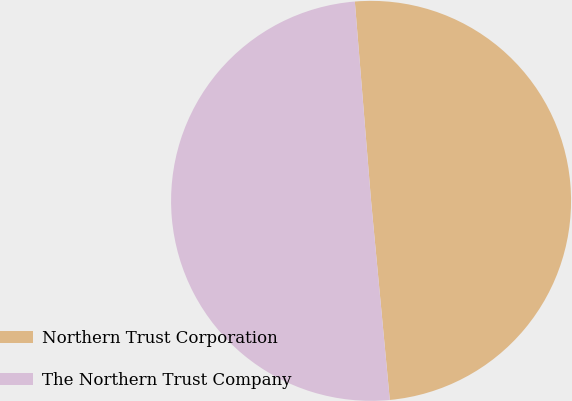Convert chart to OTSL. <chart><loc_0><loc_0><loc_500><loc_500><pie_chart><fcel>Northern Trust Corporation<fcel>The Northern Trust Company<nl><fcel>49.8%<fcel>50.2%<nl></chart> 